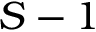Convert formula to latex. <formula><loc_0><loc_0><loc_500><loc_500>S - 1</formula> 